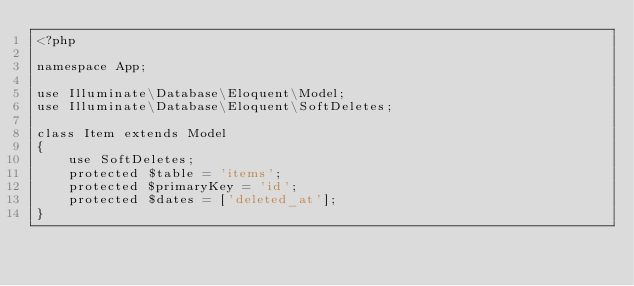<code> <loc_0><loc_0><loc_500><loc_500><_PHP_><?php

namespace App;

use Illuminate\Database\Eloquent\Model;
use Illuminate\Database\Eloquent\SoftDeletes;

class Item extends Model
{
	use SoftDeletes;
    protected $table = 'items';
    protected $primaryKey = 'id';
    protected $dates = ['deleted_at'];
}
</code> 